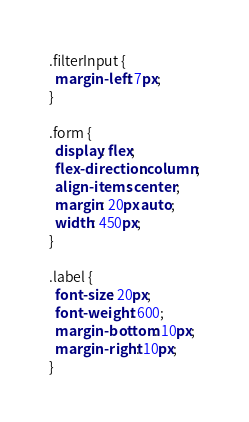Convert code to text. <code><loc_0><loc_0><loc_500><loc_500><_CSS_>.filterInput {
  margin-left: 7px;
}

.form {
  display: flex;
  flex-direction: column;
  align-items: center;
  margin: 20px auto;
  width: 450px;
}

.label {
  font-size: 20px;
  font-weight: 600;
  margin-bottom: 10px;
  margin-right: 10px;
}
</code> 